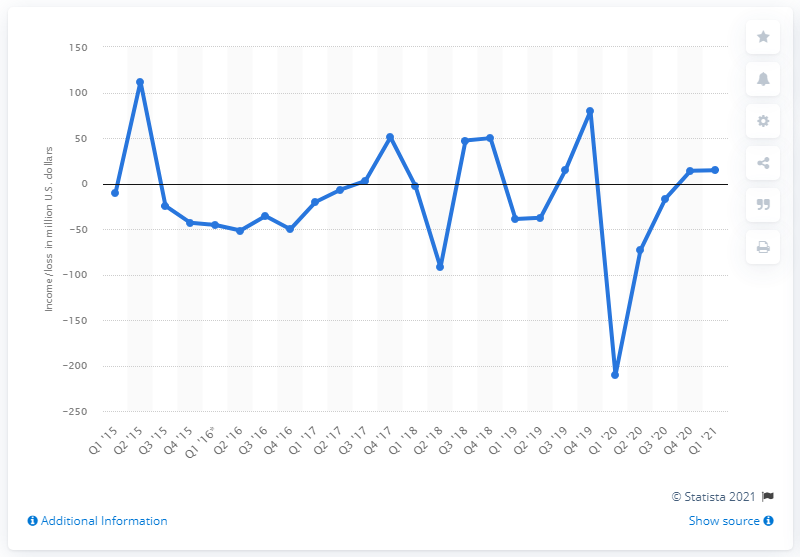Indicate a few pertinent items in this graphic. During the most recent quarter, Groupon's net income was 14.45. 